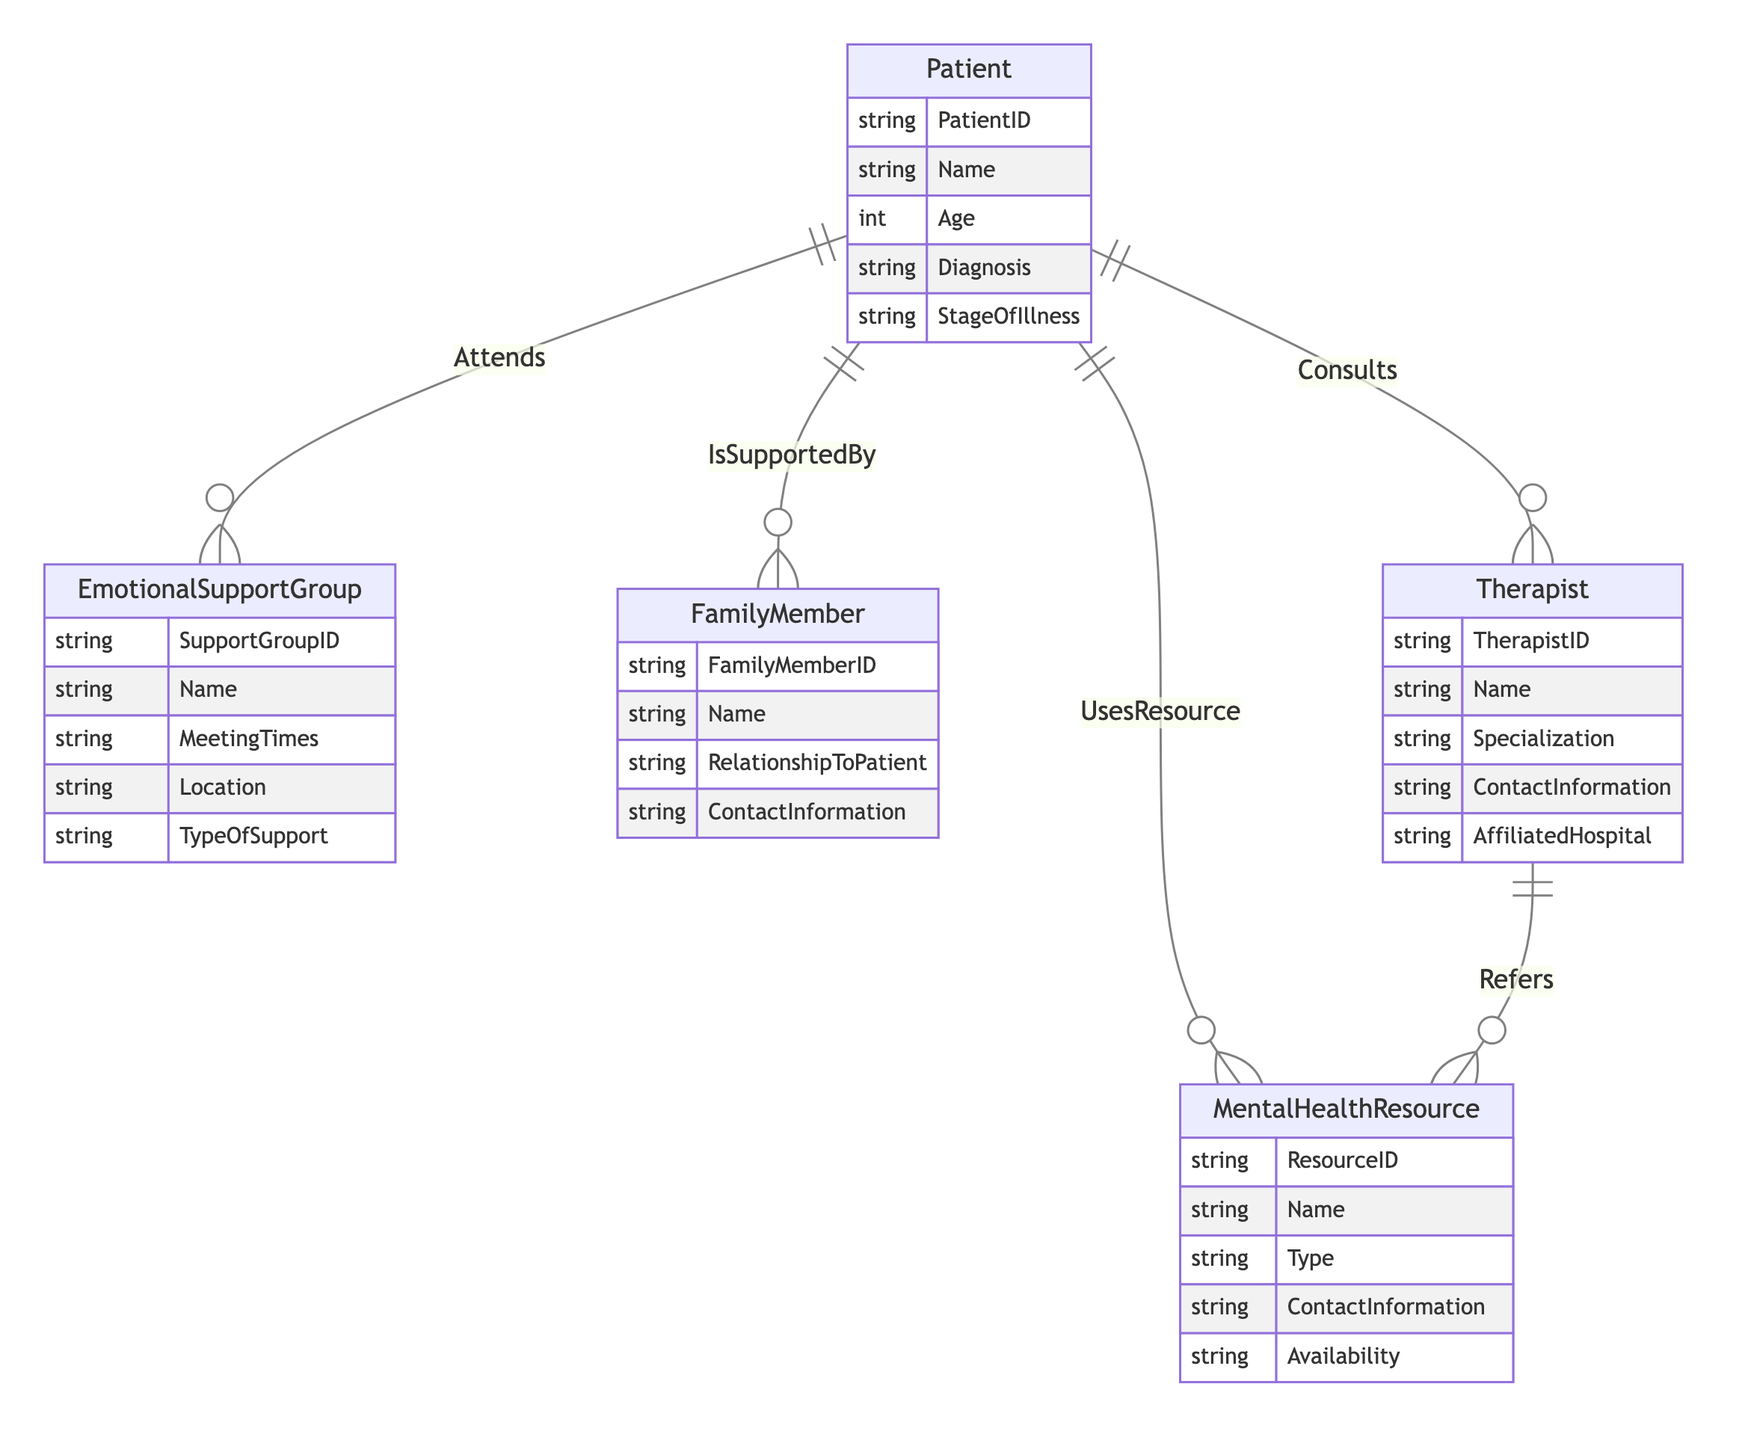What entities are involved in the diagram? The diagram includes five entities: Patient, EmotionalSupportGroup, MentalHealthResource, FamilyMember, and Therapist.
Answer: Patient, EmotionalSupportGroup, MentalHealthResource, FamilyMember, Therapist How many relationships does the Patient have? The Patient entity has four relationships: Attends (EmotionalSupportGroup), UsesResource (MentalHealthResource), IsSupportedBy (FamilyMember), and Consults (Therapist).
Answer: Four What type of support can a Patient get from FamilyMembers? The relationship "IsSupportedBy" specifies that FamilyMembers provide support, which is associated with types of support such as SupportType and SupportFrequency.
Answer: SupportType, SupportFrequency Which entity does the Therapist refer to for resources? The relationship "Refers" indicates that the Therapist entity refers the Patient to MentalHealthResources.
Answer: MentalHealthResource What is the relationship type between Patient and EmotionalSupportGroup? The relationship between Patient and EmotionalSupportGroup is called "Attends." This indicates that patients can attend support groups for emotional assistance.
Answer: Attends How is feedback gathered in the context of using mental health resources? The relationship "UsesResource" has an attribute called Feedback, which allows the Patient to provide feedback on the MentalHealthResource used.
Answer: Feedback What information does the Patient provide when consulting a Therapist? The relationship "Consults" specifies several attributes, including ConsultationDate, SessionNotes, and TherapistFeedback, which capture important information shared during Therapy sessions.
Answer: ConsultationDate, SessionNotes, TherapistFeedback What entity records the meeting times and locations for emotional support? The EmotionalSupportGroup entity contains attributes that include MeetingTimes and Location, which record details about when and where support meetings occur.
Answer: MeetingTimes, Location How many different types of mental health resources can be used by patients? The diagram includes the MentalHealthResource entity, which has an attribute called Type that categorizes the resources available to patients. Hence, the number of types depends on the instances of this entity.
Answer: Multiple types, depends on instances 